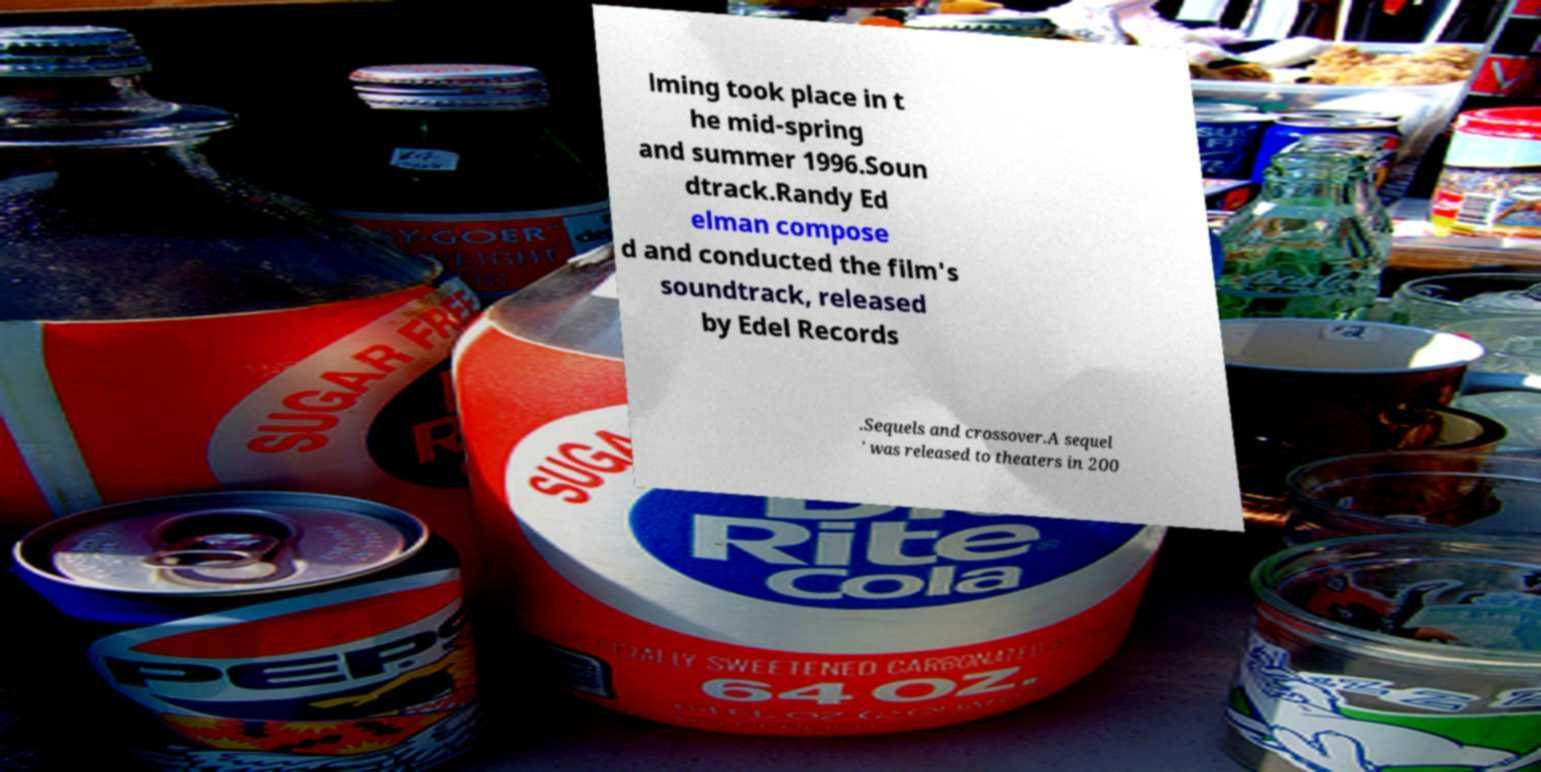I need the written content from this picture converted into text. Can you do that? lming took place in t he mid-spring and summer 1996.Soun dtrack.Randy Ed elman compose d and conducted the film's soundtrack, released by Edel Records .Sequels and crossover.A sequel ' was released to theaters in 200 